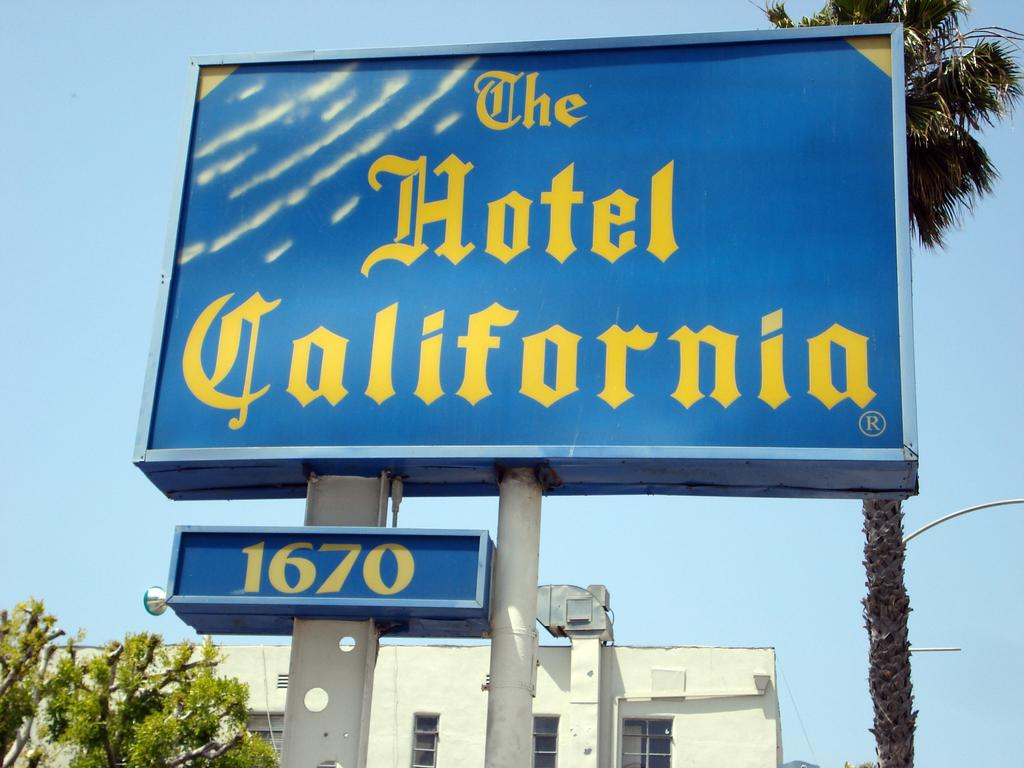<image>
Render a clear and concise summary of the photo. An advertisement on a post that says The Hotel California 1670. 